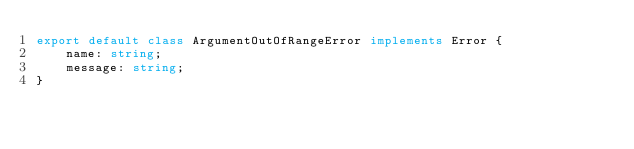<code> <loc_0><loc_0><loc_500><loc_500><_TypeScript_>export default class ArgumentOutOfRangeError implements Error {
    name: string;
    message: string;
}
</code> 